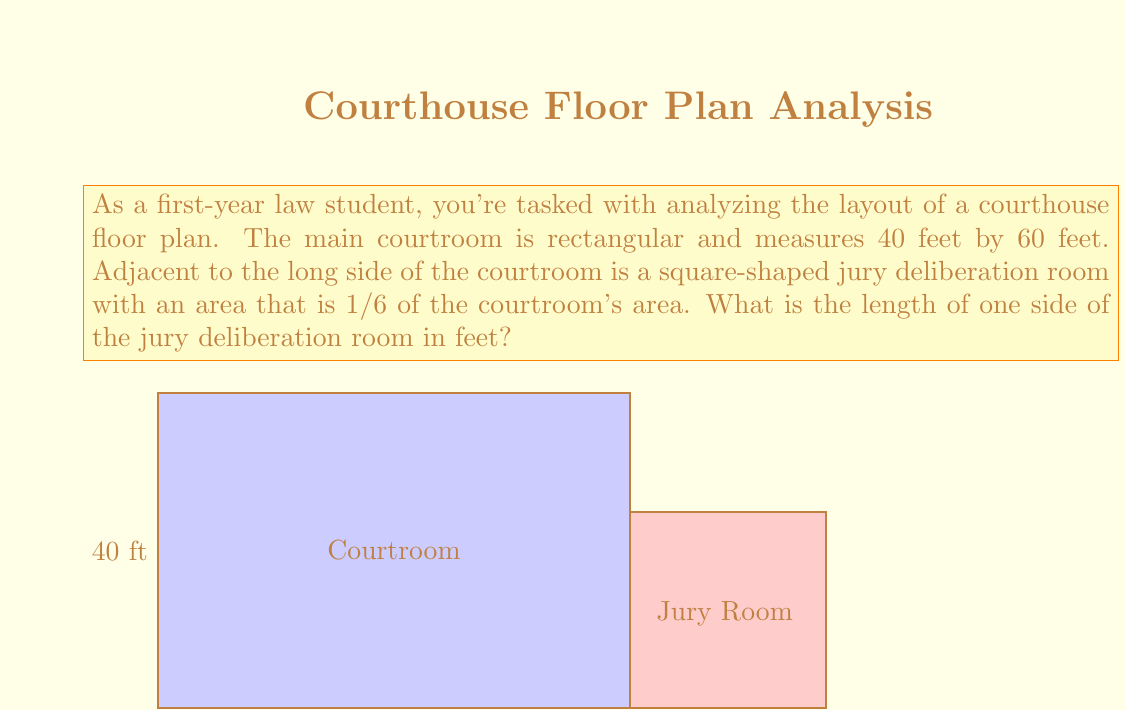Can you answer this question? Let's approach this step-by-step:

1) First, we need to calculate the area of the courtroom:
   Area of courtroom = length × width
   $$ A_{courtroom} = 60 \text{ ft} \times 40 \text{ ft} = 2400 \text{ sq ft} $$

2) The jury deliberation room's area is 1/6 of the courtroom's area:
   $$ A_{jury} = \frac{1}{6} \times A_{courtroom} = \frac{1}{6} \times 2400 \text{ sq ft} = 400 \text{ sq ft} $$

3) The jury deliberation room is square-shaped. To find the length of one side, we need to take the square root of its area:
   $$ \text{Side length} = \sqrt{A_{jury}} = \sqrt{400 \text{ sq ft}} = 20 \text{ ft} $$

This calculation gives us the length of one side of the square jury deliberation room.
Answer: 20 ft 